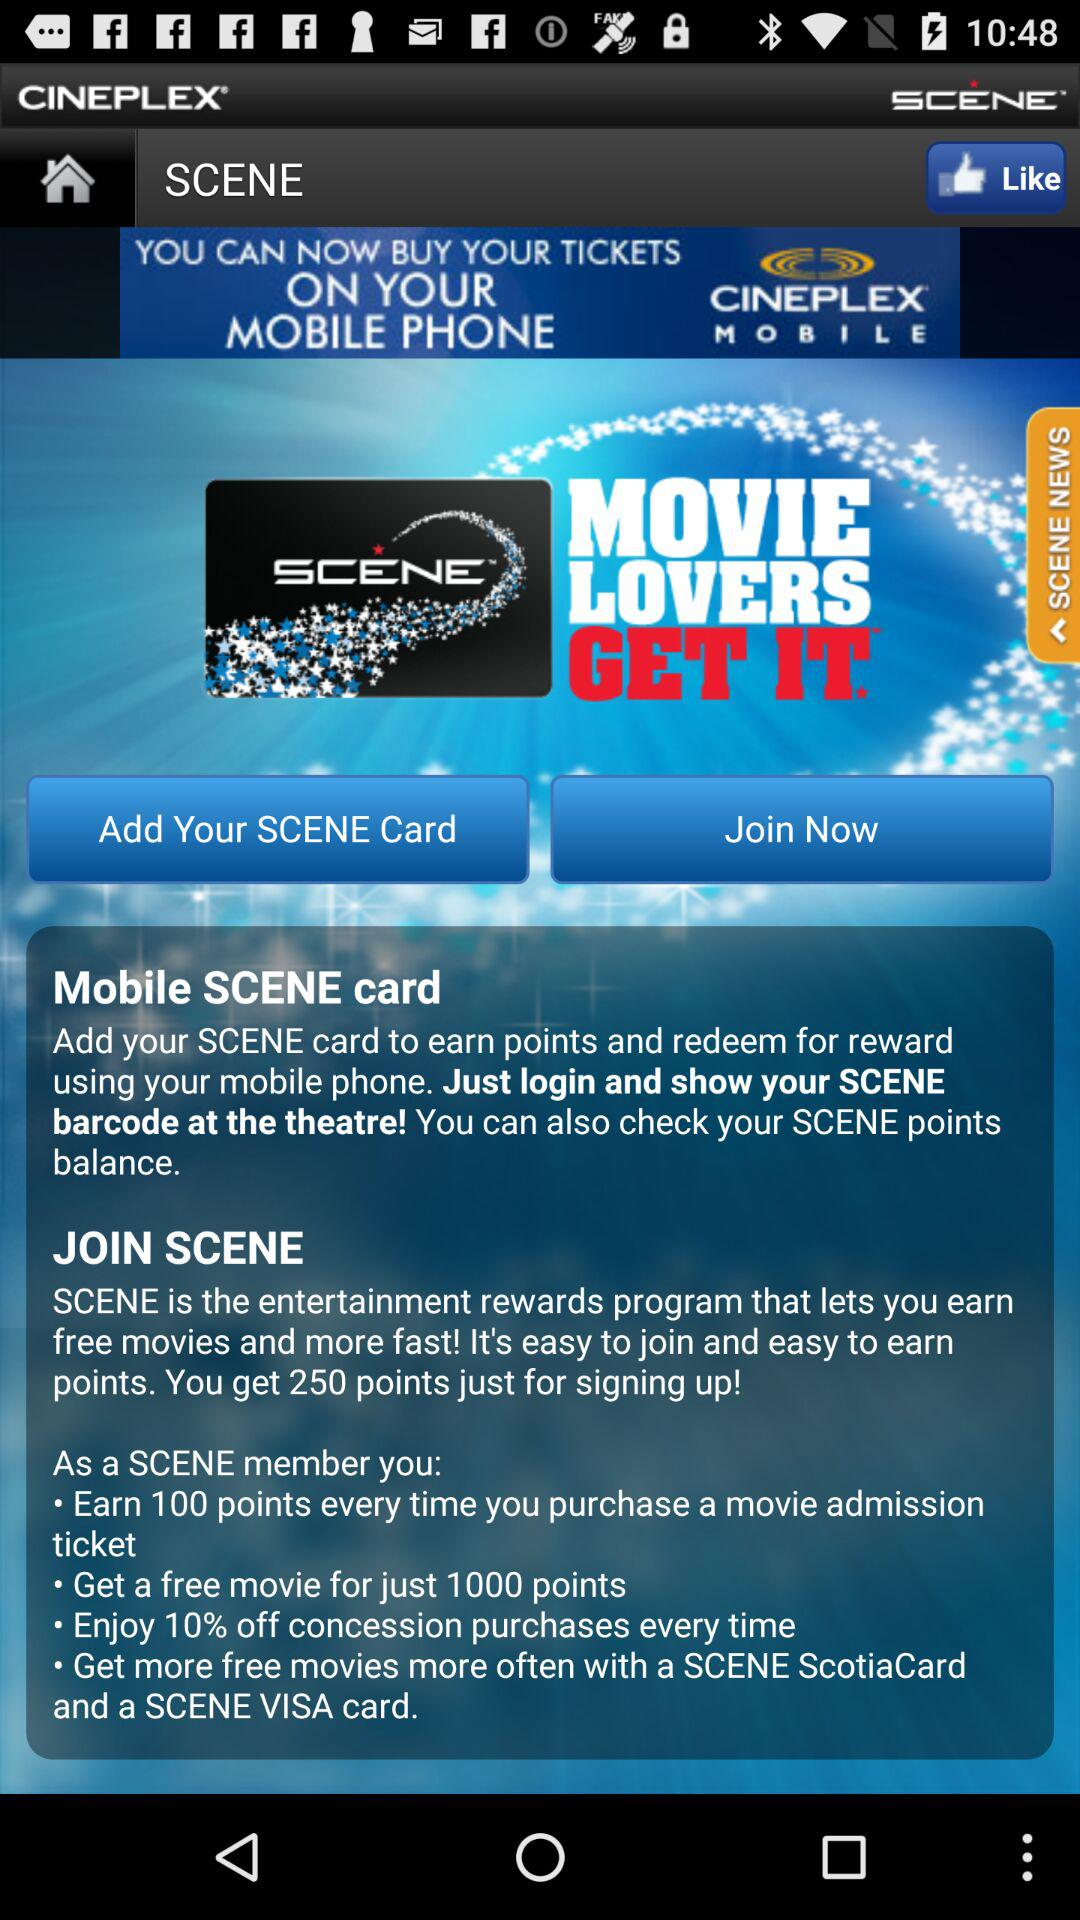What is the app's name? The app's name is "SCENE". 